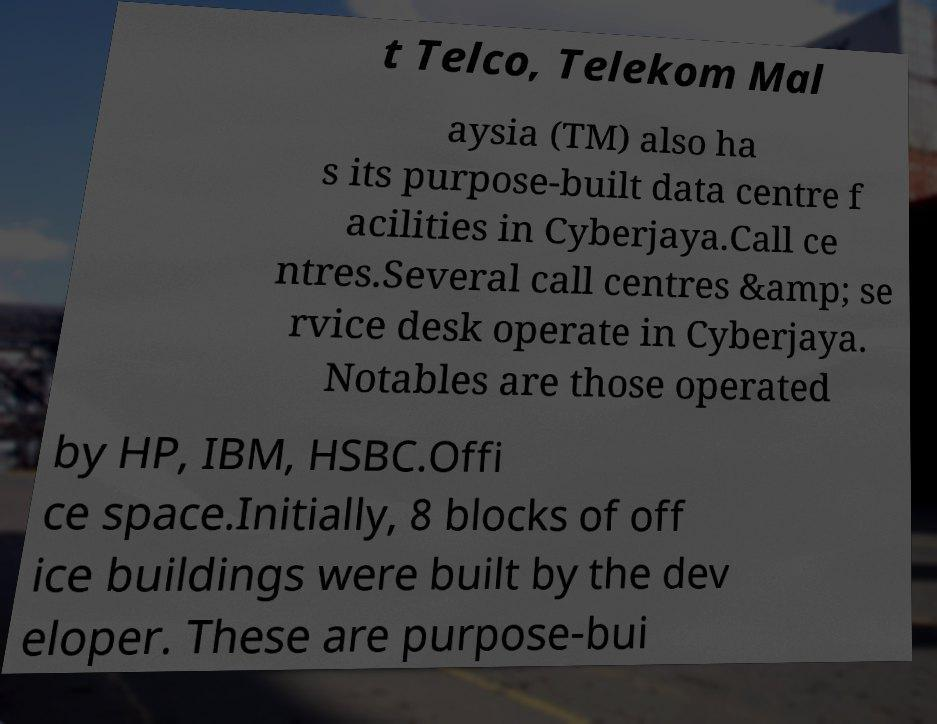Could you extract and type out the text from this image? t Telco, Telekom Mal aysia (TM) also ha s its purpose-built data centre f acilities in Cyberjaya.Call ce ntres.Several call centres &amp; se rvice desk operate in Cyberjaya. Notables are those operated by HP, IBM, HSBC.Offi ce space.Initially, 8 blocks of off ice buildings were built by the dev eloper. These are purpose-bui 